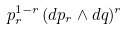<formula> <loc_0><loc_0><loc_500><loc_500>p _ { r } ^ { 1 - r } \, ( d p _ { r } \wedge d q ) ^ { r }</formula> 